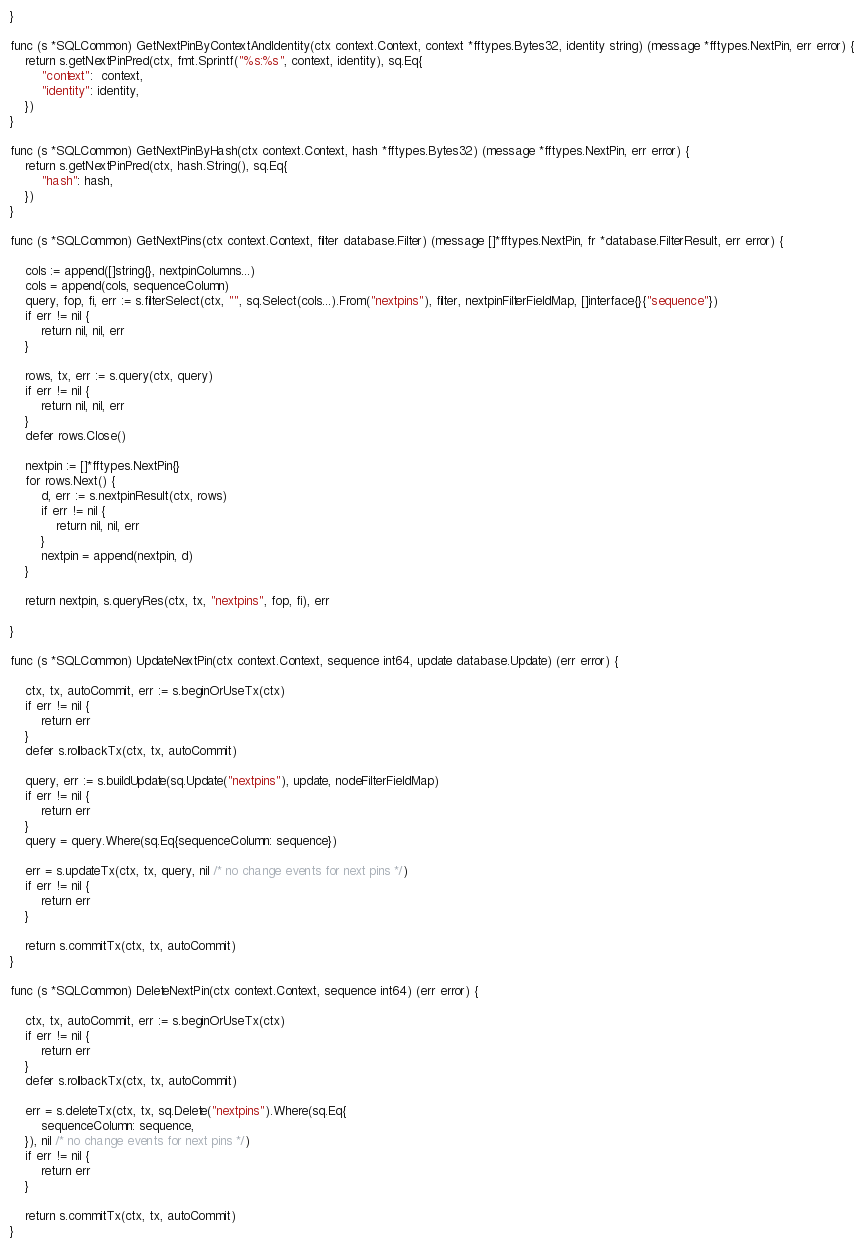Convert code to text. <code><loc_0><loc_0><loc_500><loc_500><_Go_>}

func (s *SQLCommon) GetNextPinByContextAndIdentity(ctx context.Context, context *fftypes.Bytes32, identity string) (message *fftypes.NextPin, err error) {
	return s.getNextPinPred(ctx, fmt.Sprintf("%s:%s", context, identity), sq.Eq{
		"context":  context,
		"identity": identity,
	})
}

func (s *SQLCommon) GetNextPinByHash(ctx context.Context, hash *fftypes.Bytes32) (message *fftypes.NextPin, err error) {
	return s.getNextPinPred(ctx, hash.String(), sq.Eq{
		"hash": hash,
	})
}

func (s *SQLCommon) GetNextPins(ctx context.Context, filter database.Filter) (message []*fftypes.NextPin, fr *database.FilterResult, err error) {

	cols := append([]string{}, nextpinColumns...)
	cols = append(cols, sequenceColumn)
	query, fop, fi, err := s.filterSelect(ctx, "", sq.Select(cols...).From("nextpins"), filter, nextpinFilterFieldMap, []interface{}{"sequence"})
	if err != nil {
		return nil, nil, err
	}

	rows, tx, err := s.query(ctx, query)
	if err != nil {
		return nil, nil, err
	}
	defer rows.Close()

	nextpin := []*fftypes.NextPin{}
	for rows.Next() {
		d, err := s.nextpinResult(ctx, rows)
		if err != nil {
			return nil, nil, err
		}
		nextpin = append(nextpin, d)
	}

	return nextpin, s.queryRes(ctx, tx, "nextpins", fop, fi), err

}

func (s *SQLCommon) UpdateNextPin(ctx context.Context, sequence int64, update database.Update) (err error) {

	ctx, tx, autoCommit, err := s.beginOrUseTx(ctx)
	if err != nil {
		return err
	}
	defer s.rollbackTx(ctx, tx, autoCommit)

	query, err := s.buildUpdate(sq.Update("nextpins"), update, nodeFilterFieldMap)
	if err != nil {
		return err
	}
	query = query.Where(sq.Eq{sequenceColumn: sequence})

	err = s.updateTx(ctx, tx, query, nil /* no change events for next pins */)
	if err != nil {
		return err
	}

	return s.commitTx(ctx, tx, autoCommit)
}

func (s *SQLCommon) DeleteNextPin(ctx context.Context, sequence int64) (err error) {

	ctx, tx, autoCommit, err := s.beginOrUseTx(ctx)
	if err != nil {
		return err
	}
	defer s.rollbackTx(ctx, tx, autoCommit)

	err = s.deleteTx(ctx, tx, sq.Delete("nextpins").Where(sq.Eq{
		sequenceColumn: sequence,
	}), nil /* no change events for next pins */)
	if err != nil {
		return err
	}

	return s.commitTx(ctx, tx, autoCommit)
}
</code> 